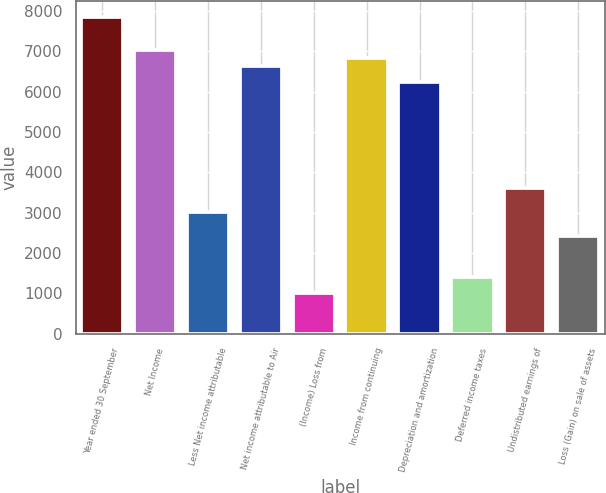<chart> <loc_0><loc_0><loc_500><loc_500><bar_chart><fcel>Year ended 30 September<fcel>Net Income<fcel>Less Net income attributable<fcel>Net income attributable to Air<fcel>(Income) Loss from<fcel>Income from continuing<fcel>Depreciation and amortization<fcel>Deferred income taxes<fcel>Undistributed earnings of<fcel>Loss (Gain) on sale of assets<nl><fcel>7847.22<fcel>7042.5<fcel>3018.9<fcel>6640.14<fcel>1007.1<fcel>6841.32<fcel>6237.78<fcel>1409.46<fcel>3622.44<fcel>2415.36<nl></chart> 